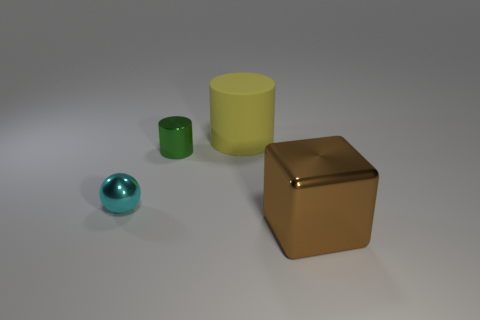Is there a big block that has the same color as the tiny metal cylinder?
Ensure brevity in your answer.  No. What is the color of the matte cylinder that is the same size as the brown cube?
Offer a terse response. Yellow. What number of tiny things are green rubber objects or green objects?
Keep it short and to the point. 1. Is the number of brown blocks that are behind the large yellow object the same as the number of large metallic objects on the left side of the large brown metal thing?
Offer a terse response. Yes. How many brown objects have the same size as the ball?
Offer a terse response. 0. How many brown objects are either shiny cylinders or cubes?
Your answer should be compact. 1. Are there an equal number of cyan balls on the right side of the yellow matte cylinder and big things?
Make the answer very short. No. How big is the metallic object in front of the ball?
Ensure brevity in your answer.  Large. What number of brown metallic things have the same shape as the cyan thing?
Your response must be concise. 0. There is a object that is in front of the small cylinder and on the left side of the rubber object; what is its material?
Your answer should be compact. Metal. 